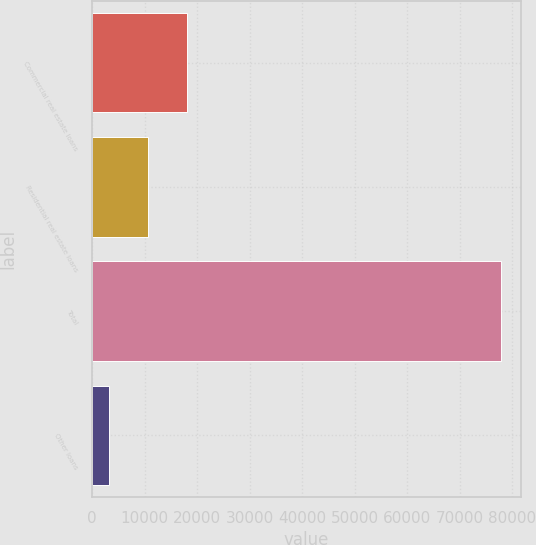<chart> <loc_0><loc_0><loc_500><loc_500><bar_chart><fcel>Commercial real estate loans<fcel>Residential real estate loans<fcel>Total<fcel>Other loans<nl><fcel>18098.4<fcel>10638.7<fcel>77776<fcel>3179<nl></chart> 